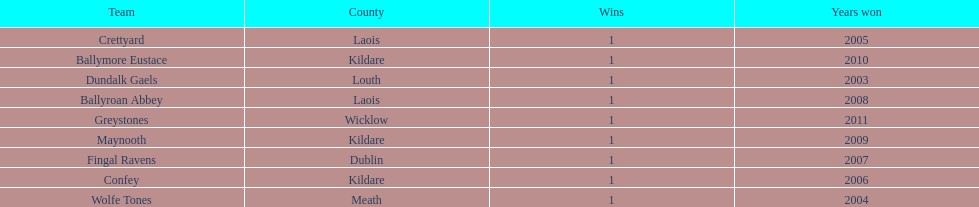What team comes before confey Fingal Ravens. 